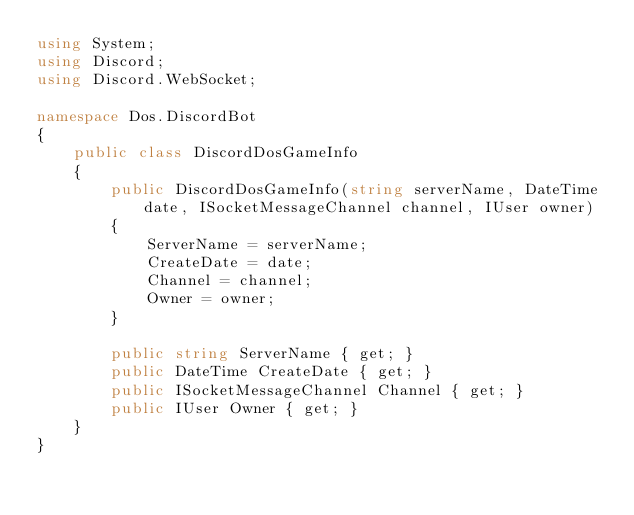Convert code to text. <code><loc_0><loc_0><loc_500><loc_500><_C#_>using System;
using Discord;
using Discord.WebSocket;

namespace Dos.DiscordBot
{
    public class DiscordDosGameInfo
    {
        public DiscordDosGameInfo(string serverName, DateTime date, ISocketMessageChannel channel, IUser owner)
        {
            ServerName = serverName;
            CreateDate = date;
            Channel = channel;
            Owner = owner;
        }

        public string ServerName { get; }
        public DateTime CreateDate { get; }
        public ISocketMessageChannel Channel { get; }
        public IUser Owner { get; }
    }
}
</code> 